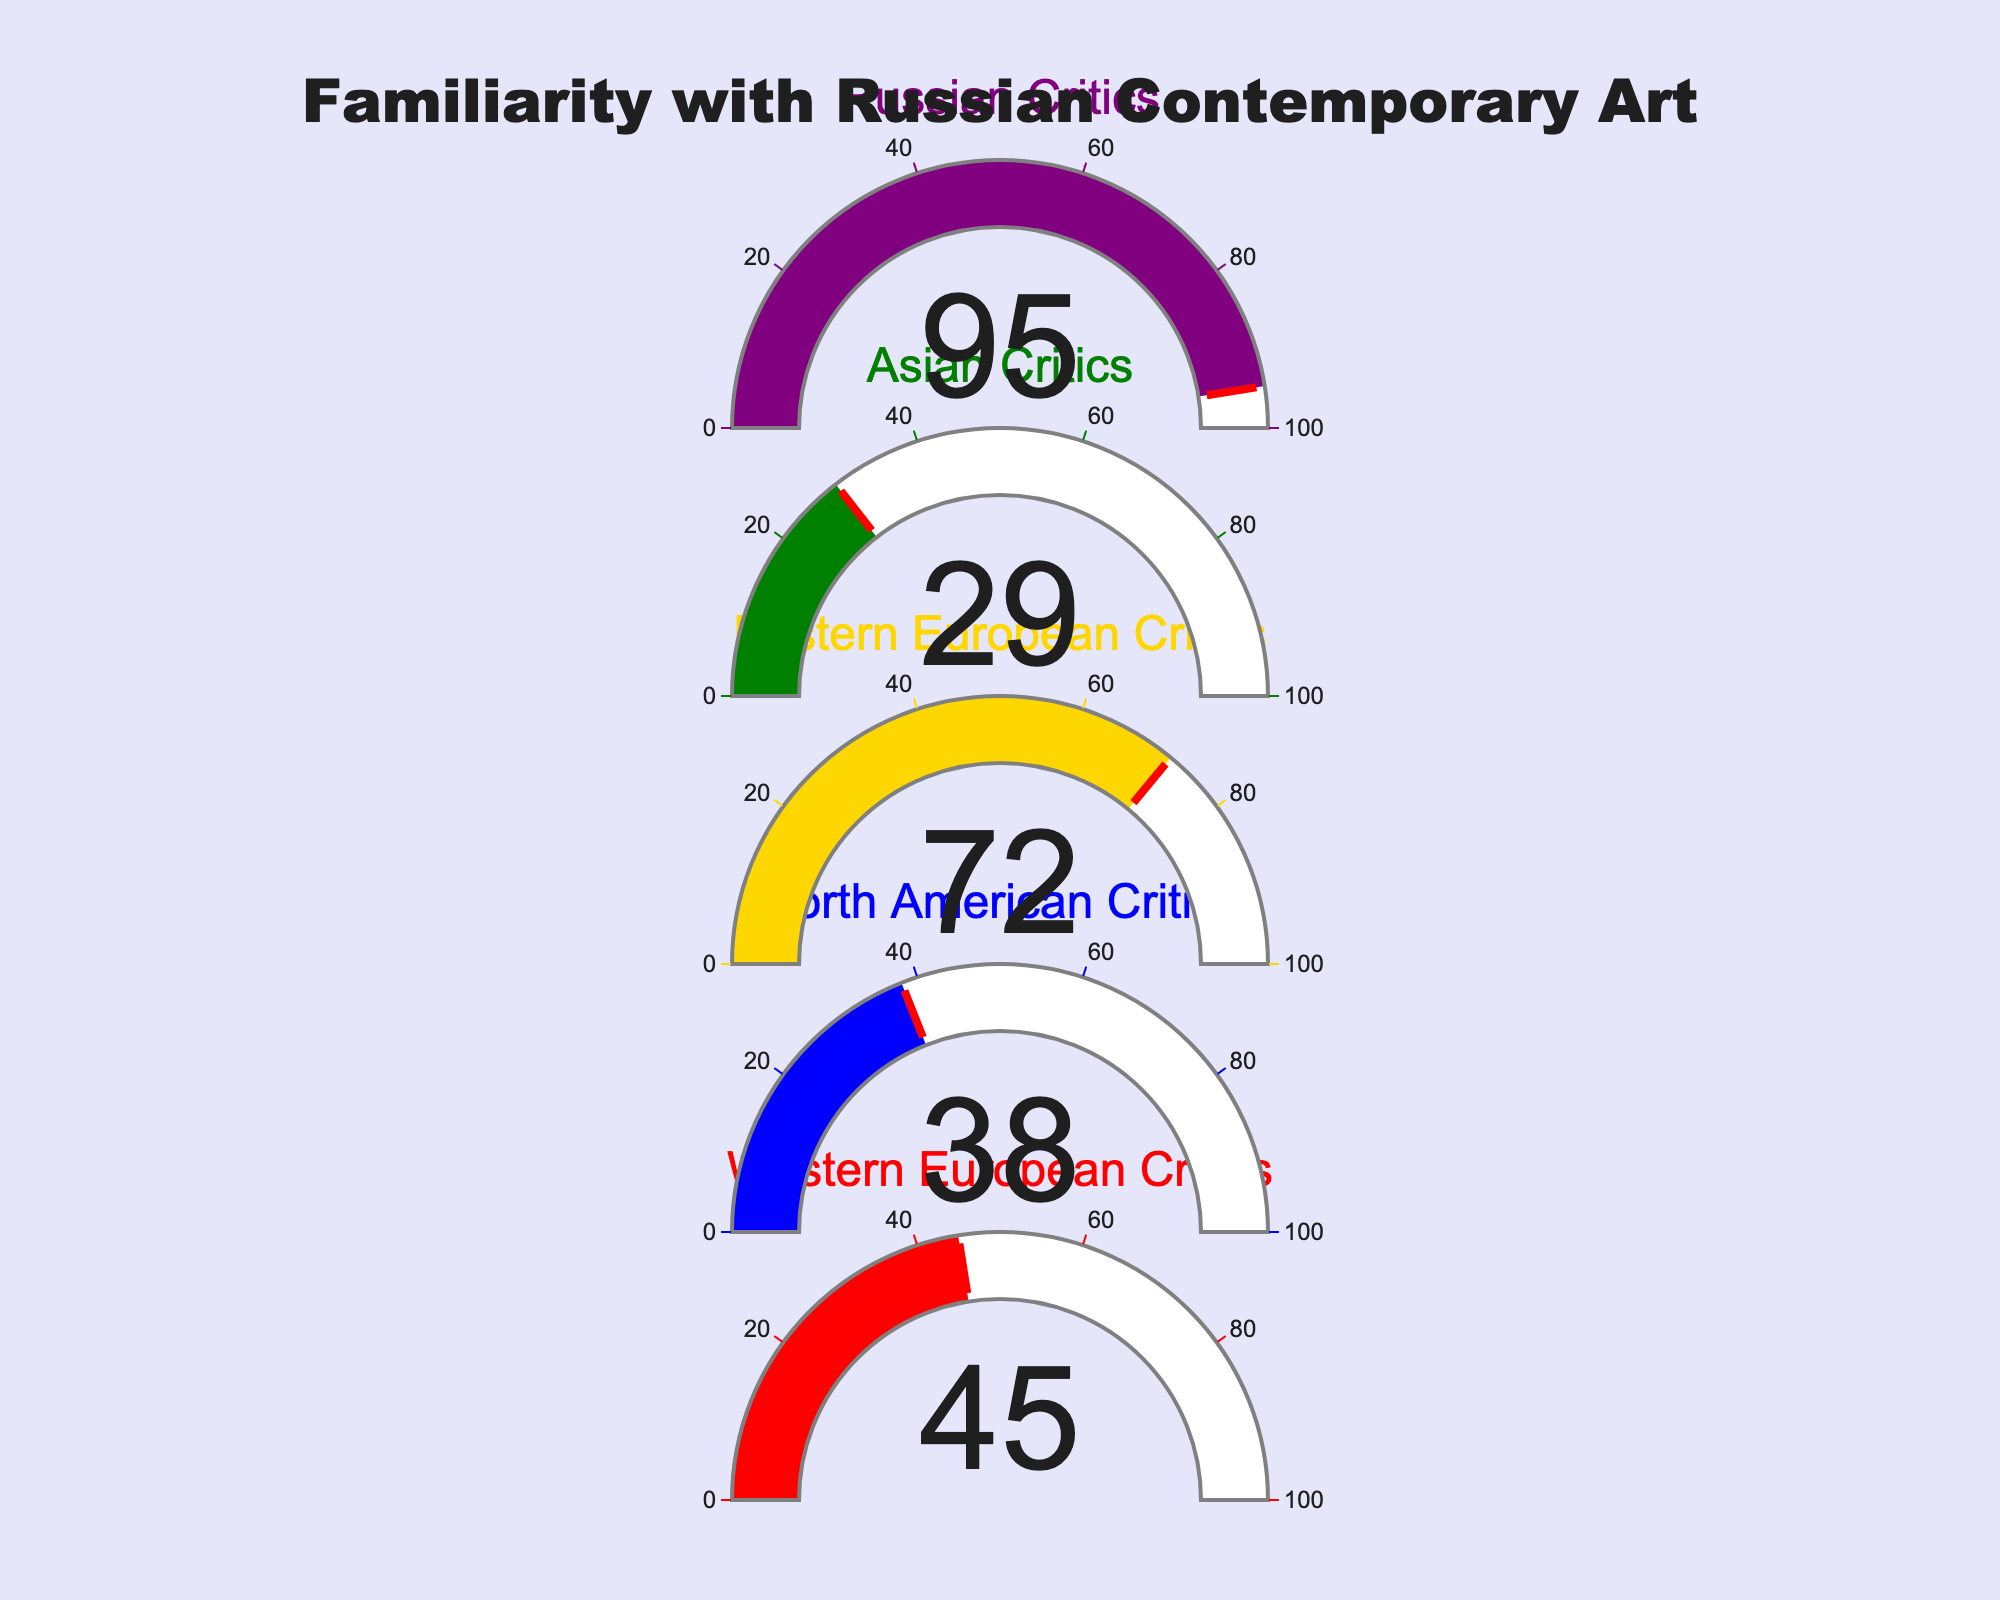What is the title of the figure? The title is displayed at the top center of the figure with larger font size indicating the main subject.
Answer: Familiarity with Russian Contemporary Art How many critic groups are displayed in the figure? By counting the number of separate gauges presented in the figure, we can determine the number of critic groups represented.
Answer: 5 Which critic group has the highest familiarity percentage with Russian contemporary art movements? By comparing the values shown on each gauge, we can see that the Russian Critics have the highest familiarity percentage.
Answer: Russian Critics What is the difference in familiarity percentage between Western European Critics and North American Critics? Subtract the percentage of North American Critics from Western European Critics (45 - 38).
Answer: 7 What is the average familiarity percentage across all critic groups? Summing all the given percentages (45 + 38 + 72 + 29 + 95) and dividing by the number of critic groups (5).
Answer: 55.8 Which critic group has the lowest familiarity percentage with Russian contemporary art movements? By comparing the values on each gauge, it becomes clear that the Asian Critics have the lowest familiarity percentage.
Answer: Asian Critics How much more familiar are Eastern European Critics compared to Asian Critics? Subtract the percentage of Asian Critics from Eastern European Critics (72 - 29).
Answer: 43 Is the familiarity percentage of Eastern European Critics greater than the average familiarity percentage across all groups? Calculate the average familiarity percentage (55.8) and then compare it to the Eastern European Critics' percentage (72).
Answer: Yes What percentage value does the gauge specific for Russian Critics show? The gauge labeled Russian Critics clearly indicates their familiarity percentage.
Answer: 95 What is the median familiarity percentage among all the critic groups? List the percentages in order (29, 38, 45, 72, 95) and find the middle value.
Answer: 45 